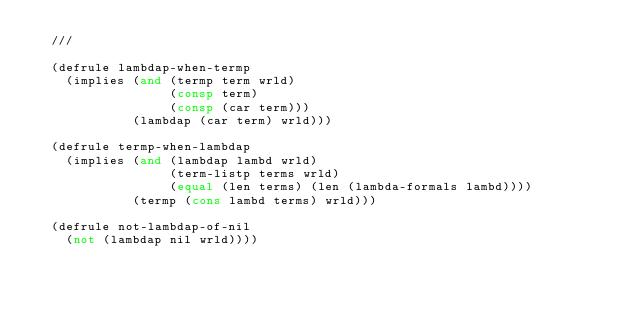Convert code to text. <code><loc_0><loc_0><loc_500><loc_500><_Lisp_>  ///

  (defrule lambdap-when-termp
    (implies (and (termp term wrld)
                  (consp term)
                  (consp (car term)))
             (lambdap (car term) wrld)))

  (defrule termp-when-lambdap
    (implies (and (lambdap lambd wrld)
                  (term-listp terms wrld)
                  (equal (len terms) (len (lambda-formals lambd))))
             (termp (cons lambd terms) wrld)))

  (defrule not-lambdap-of-nil
    (not (lambdap nil wrld))))
</code> 